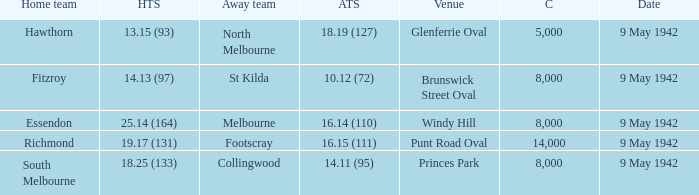How many people attended the game with the home team scoring 18.25 (133)? 1.0. 